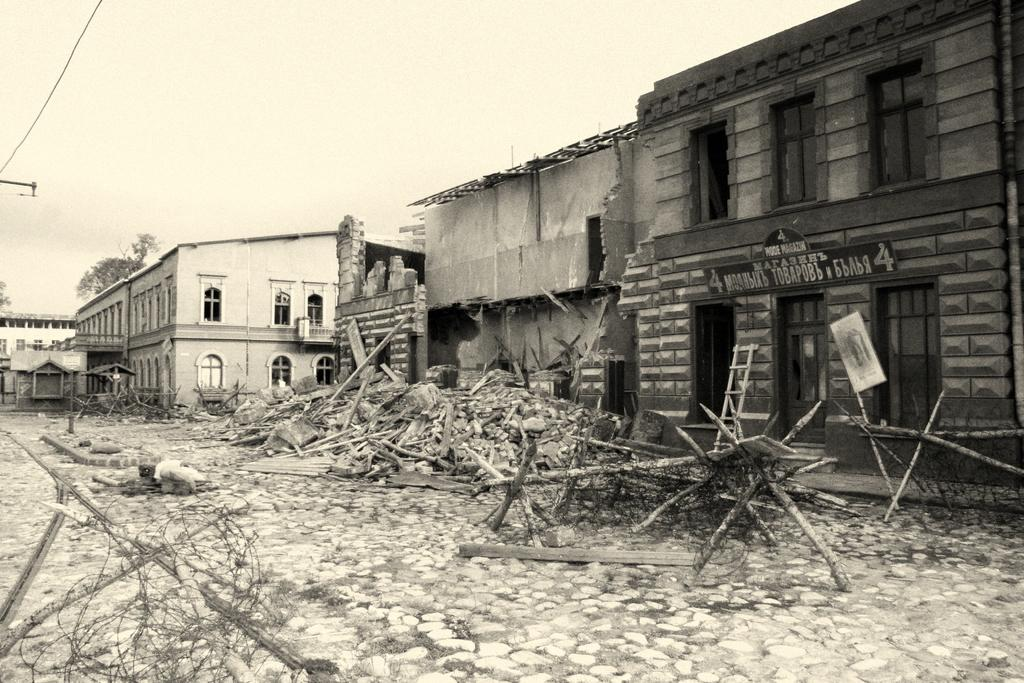What is the condition of the house in the image? The house in the image is damaged. What can be seen on the ground in front of the house? There are wooden rafters on the dry ground in front of the house. What is located in the background of the image? There is a white-colored shade house in the background. Where is the giraffe sleeping in the image? There is no giraffe present in the image. What is the top of the damaged house made of in the image? The provided facts do not mention the material of the house's top, so we cannot answer this question definitively. 